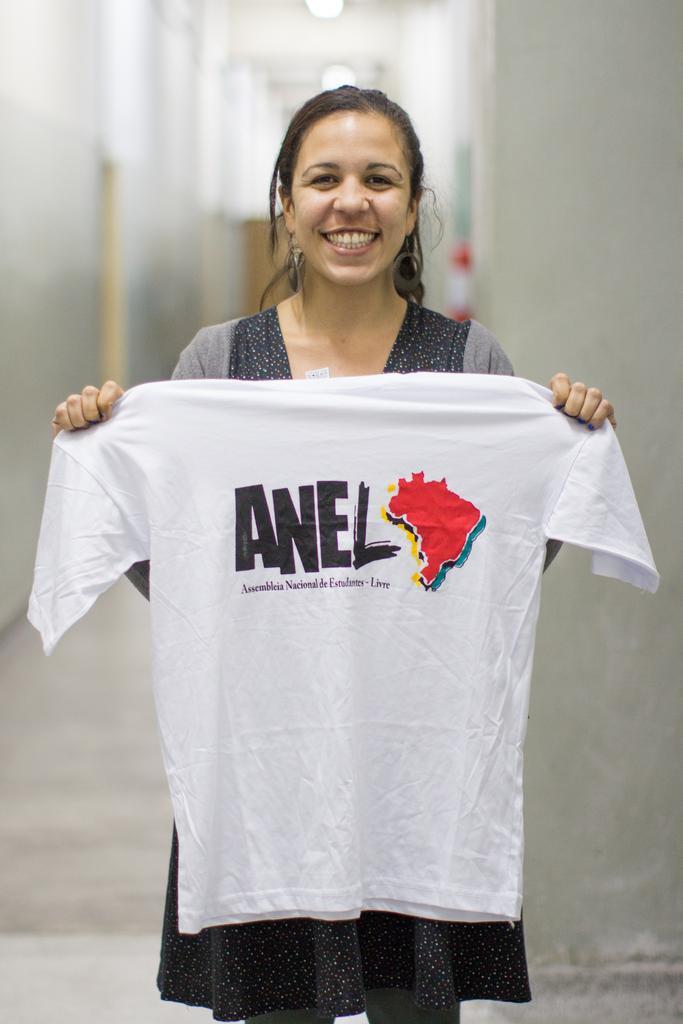Describe this image in one or two sentences. The woman in front of the picture is wearing a grey and black dress. She is standing and she is holding a white T-shirt in her hands. She is smiling. Behind her, we see a white wall. At the top, we see the lights and the ceiling of the room. This picture is blurred in the background. 